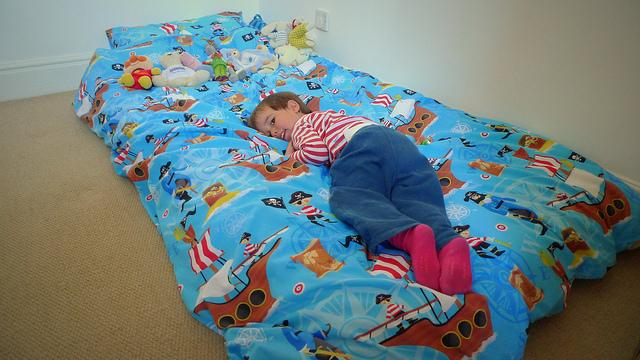The boy is wearing a shirt that looks like the shirt of a character in what series?

Choices:
A) smurfs
B) curious george
C) where's waldo
D) garfield where's waldo 